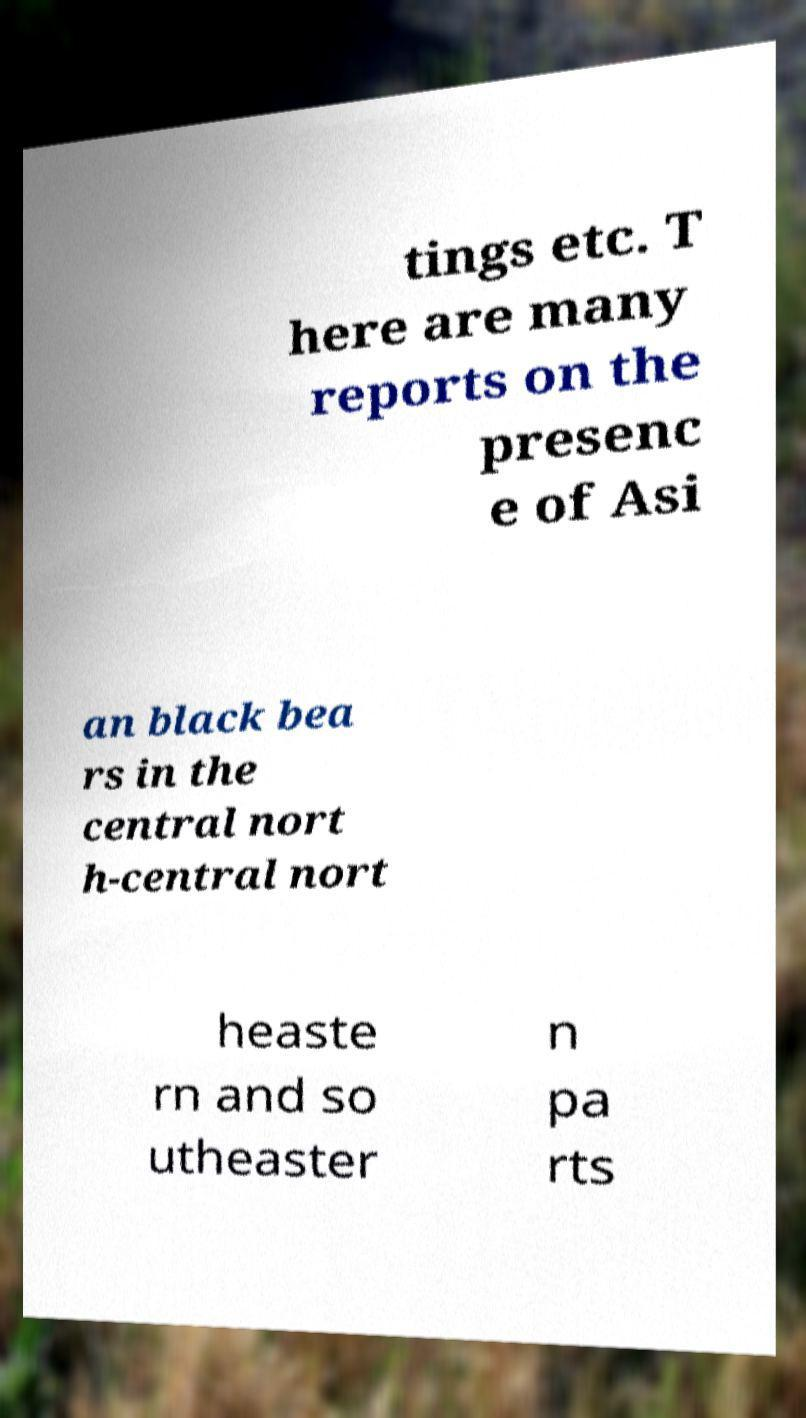For documentation purposes, I need the text within this image transcribed. Could you provide that? tings etc. T here are many reports on the presenc e of Asi an black bea rs in the central nort h-central nort heaste rn and so utheaster n pa rts 